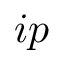<formula> <loc_0><loc_0><loc_500><loc_500>i p</formula> 